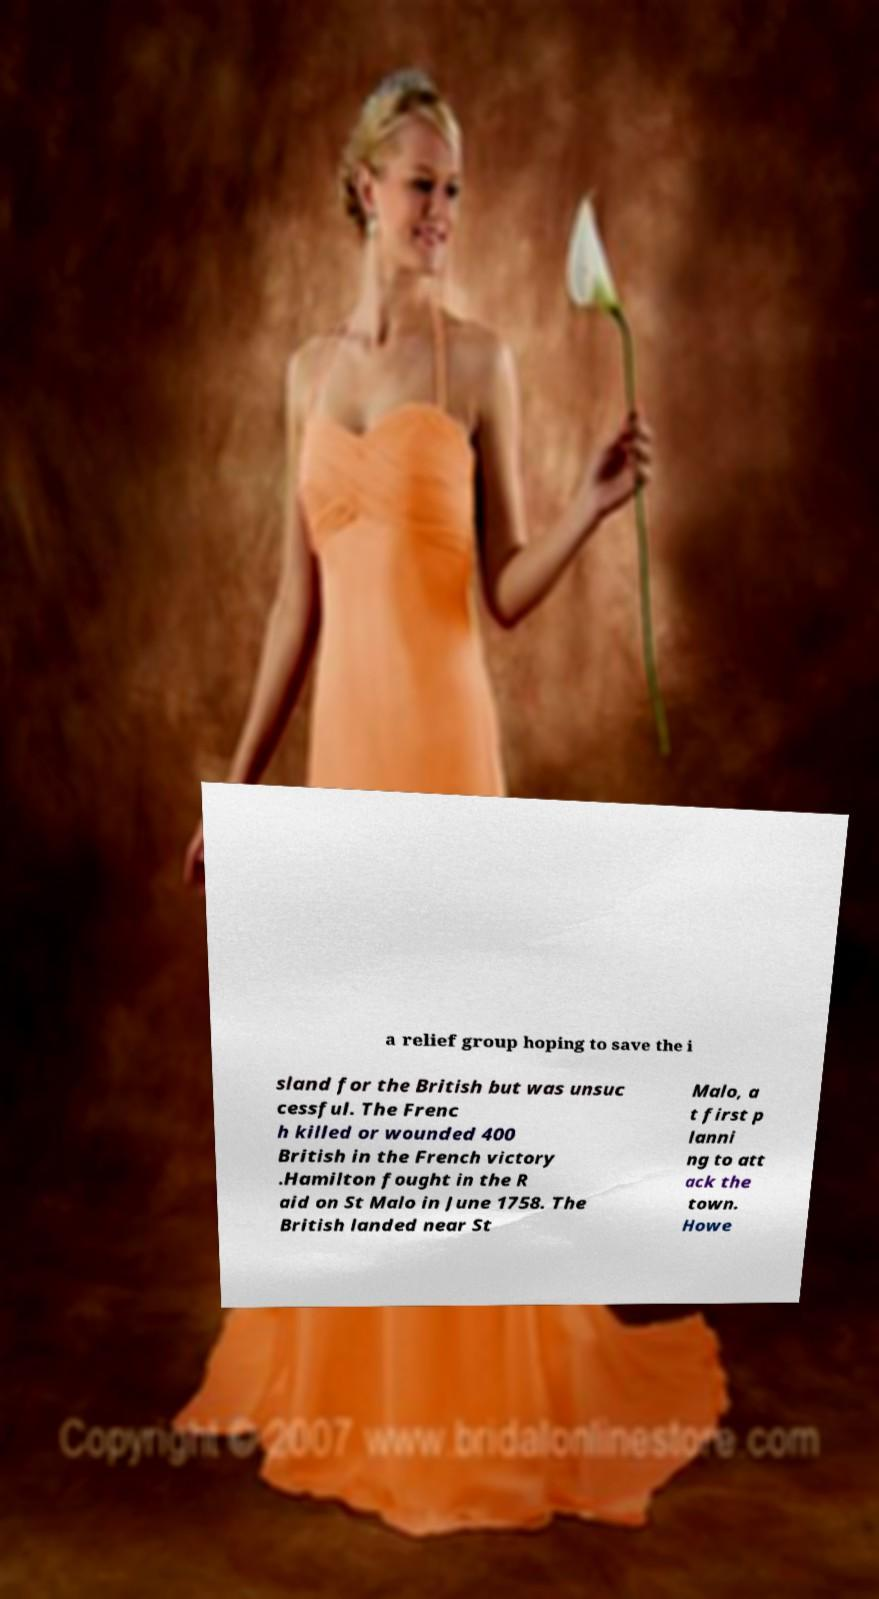I need the written content from this picture converted into text. Can you do that? a relief group hoping to save the i sland for the British but was unsuc cessful. The Frenc h killed or wounded 400 British in the French victory .Hamilton fought in the R aid on St Malo in June 1758. The British landed near St Malo, a t first p lanni ng to att ack the town. Howe 